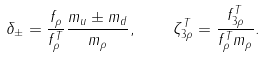Convert formula to latex. <formula><loc_0><loc_0><loc_500><loc_500>\delta _ { \pm } = \frac { f _ { \rho } } { f _ { \rho } ^ { T } } \frac { m _ { u } \pm m _ { d } } { m _ { \rho } } , \quad \zeta _ { 3 \rho } ^ { T } = \frac { f _ { 3 \rho } ^ { T } } { f _ { \rho } ^ { T } m _ { \rho } } .</formula> 